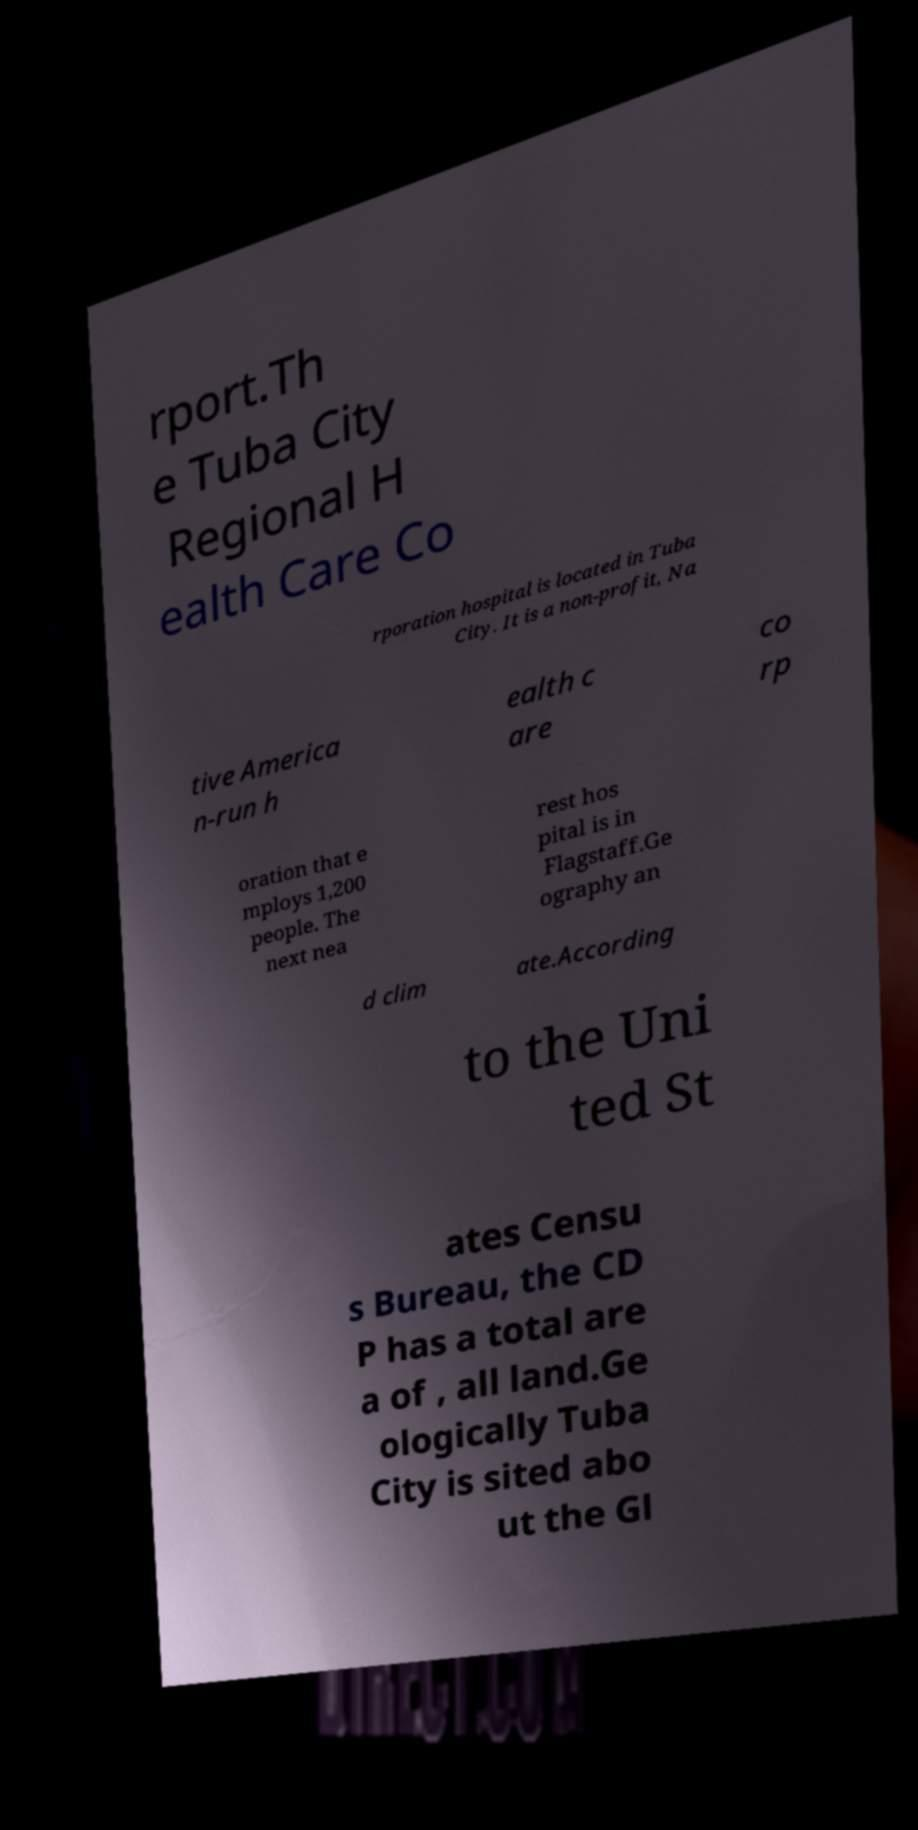Please identify and transcribe the text found in this image. rport.Th e Tuba City Regional H ealth Care Co rporation hospital is located in Tuba City. It is a non-profit, Na tive America n-run h ealth c are co rp oration that e mploys 1,200 people. The next nea rest hos pital is in Flagstaff.Ge ography an d clim ate.According to the Uni ted St ates Censu s Bureau, the CD P has a total are a of , all land.Ge ologically Tuba City is sited abo ut the Gl 